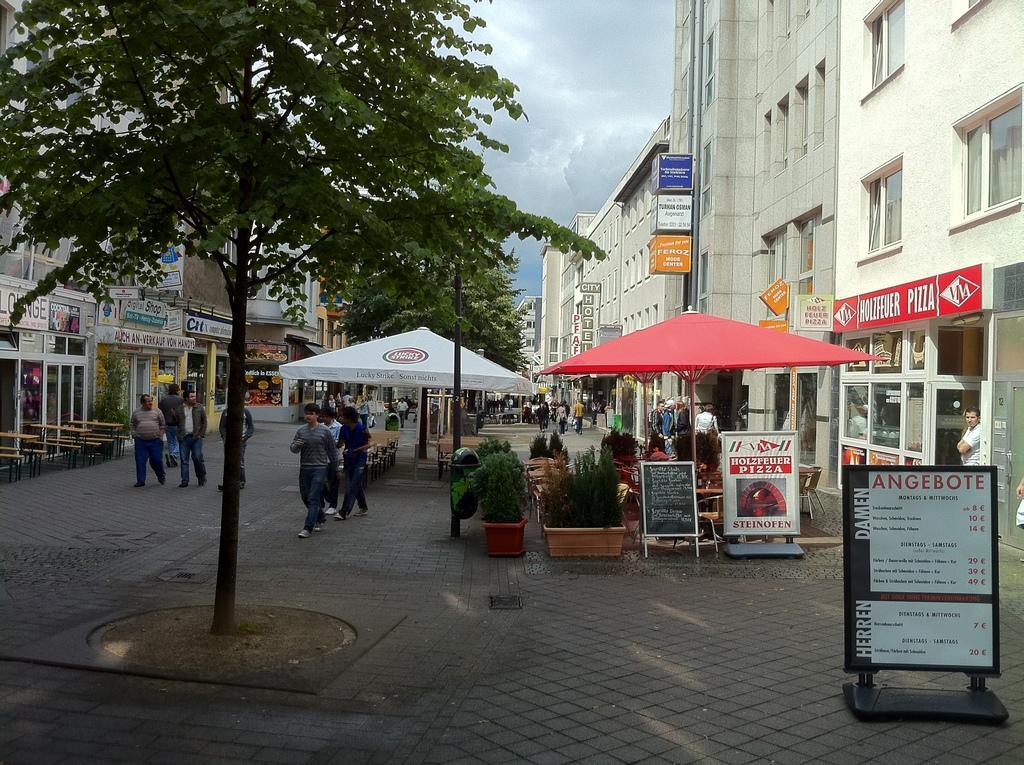How would you summarize this image in a sentence or two? In this picture we can see few buildings, trees, tents and group of people, in the background we can find few hoardings and clouds. 